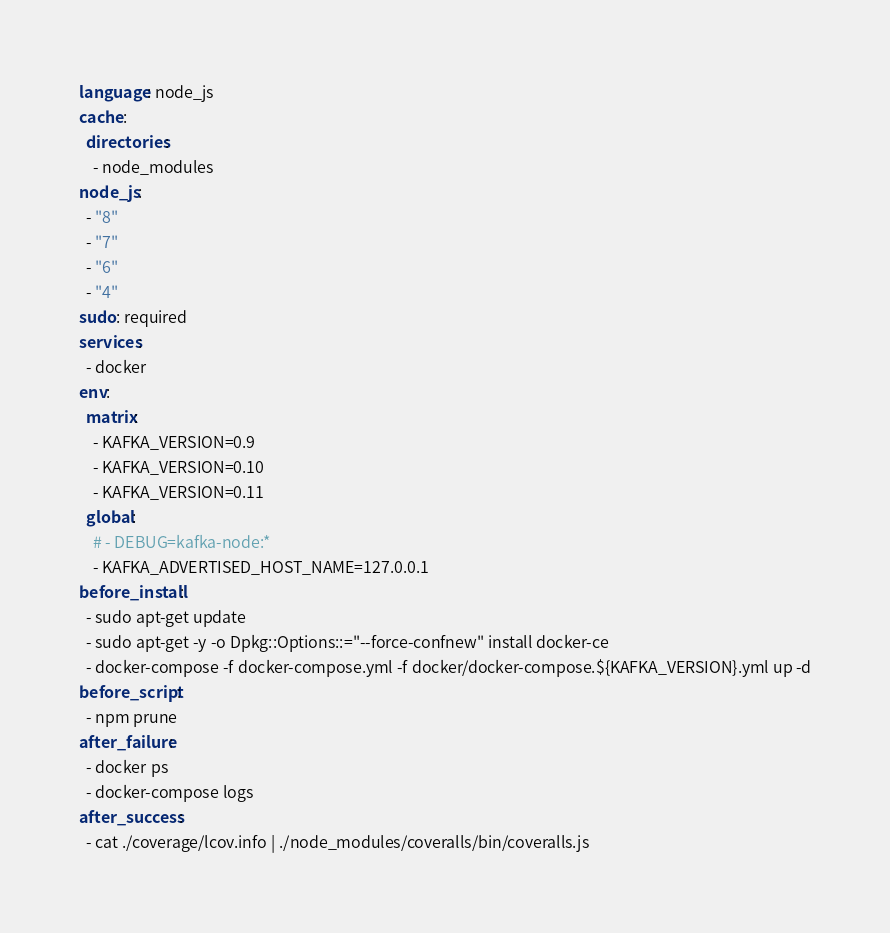Convert code to text. <code><loc_0><loc_0><loc_500><loc_500><_YAML_>language: node_js
cache:
  directories:
    - node_modules
node_js:
  - "8"
  - "7"
  - "6"
  - "4"
sudo: required
services:
  - docker
env:
  matrix:
    - KAFKA_VERSION=0.9
    - KAFKA_VERSION=0.10
    - KAFKA_VERSION=0.11
  global:
    # - DEBUG=kafka-node:*
    - KAFKA_ADVERTISED_HOST_NAME=127.0.0.1
before_install:
  - sudo apt-get update
  - sudo apt-get -y -o Dpkg::Options::="--force-confnew" install docker-ce
  - docker-compose -f docker-compose.yml -f docker/docker-compose.${KAFKA_VERSION}.yml up -d
before_script:
  - npm prune
after_failure:
  - docker ps
  - docker-compose logs
after_success:
  - cat ./coverage/lcov.info | ./node_modules/coveralls/bin/coveralls.js
</code> 